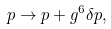Convert formula to latex. <formula><loc_0><loc_0><loc_500><loc_500>p \rightarrow p + g ^ { 6 } \delta p ,</formula> 